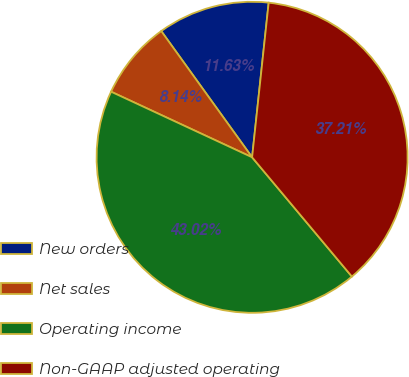<chart> <loc_0><loc_0><loc_500><loc_500><pie_chart><fcel>New orders<fcel>Net sales<fcel>Operating income<fcel>Non-GAAP adjusted operating<nl><fcel>11.63%<fcel>8.14%<fcel>43.02%<fcel>37.21%<nl></chart> 